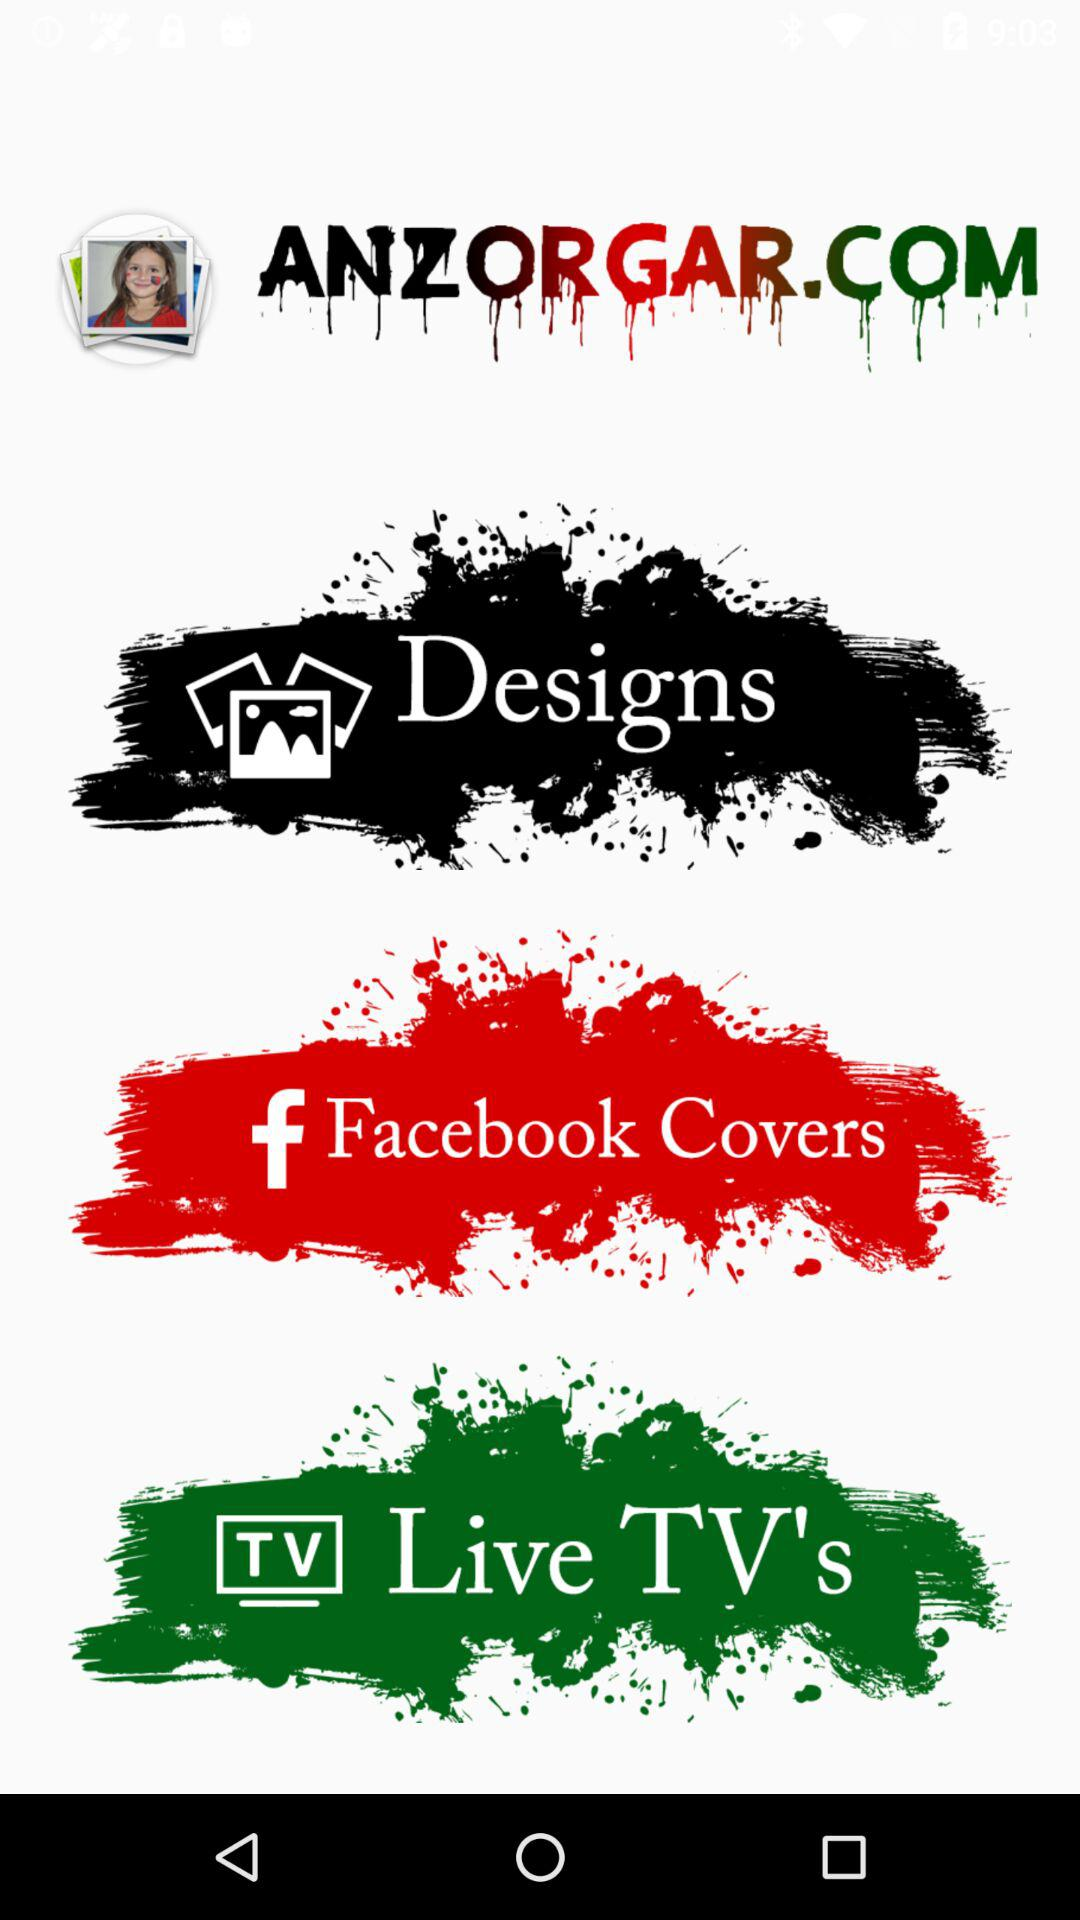What is the name of the application? The application name is "ANZORGAR.COM". 